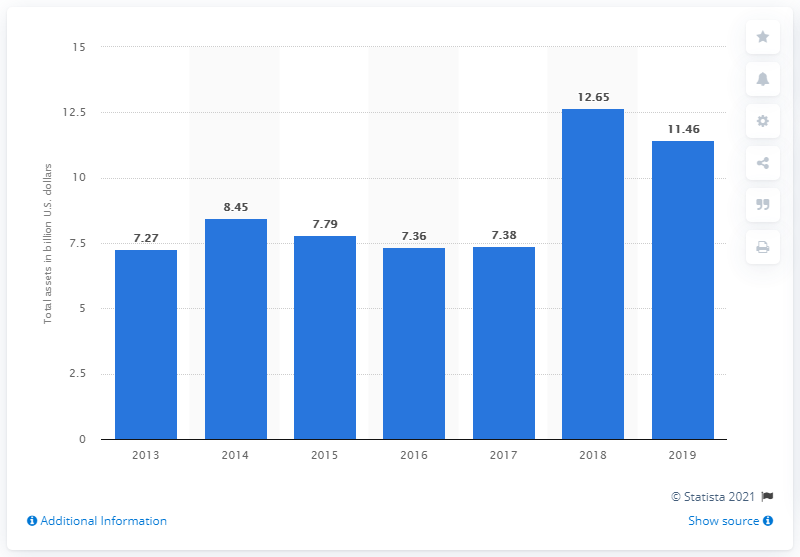Indicate a few pertinent items in this graphic. In 2019, Jacob Engineering Group's assets were valued at approximately 11.46 dollars. 